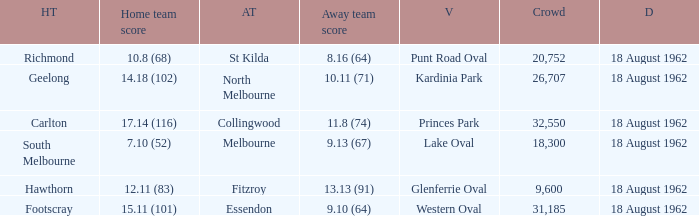What was the home team when the away team scored 9.10 (64)? Footscray. 